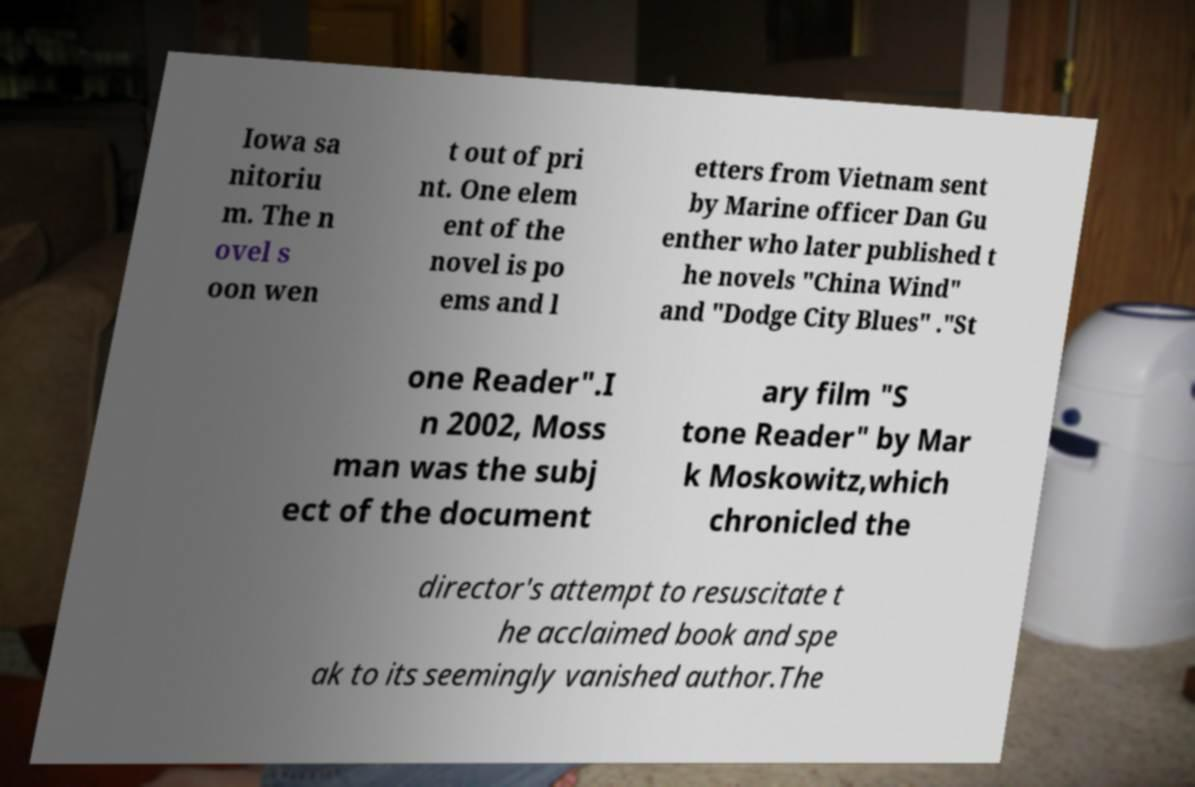Please identify and transcribe the text found in this image. Iowa sa nitoriu m. The n ovel s oon wen t out of pri nt. One elem ent of the novel is po ems and l etters from Vietnam sent by Marine officer Dan Gu enther who later published t he novels "China Wind" and "Dodge City Blues" ."St one Reader".I n 2002, Moss man was the subj ect of the document ary film "S tone Reader" by Mar k Moskowitz,which chronicled the director's attempt to resuscitate t he acclaimed book and spe ak to its seemingly vanished author.The 